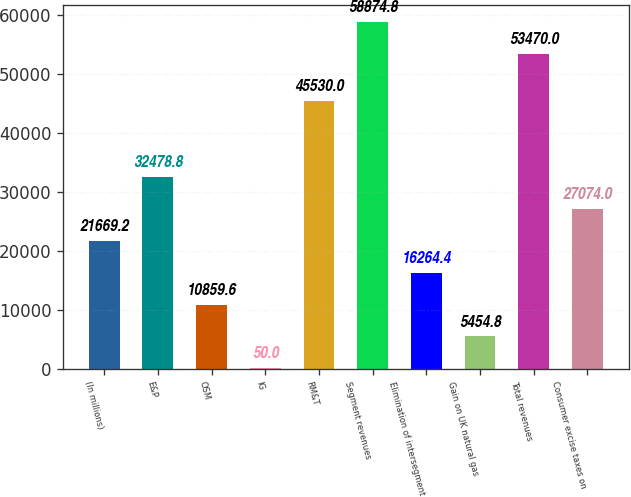Convert chart. <chart><loc_0><loc_0><loc_500><loc_500><bar_chart><fcel>(In millions)<fcel>E&P<fcel>OSM<fcel>IG<fcel>RM&T<fcel>Segment revenues<fcel>Elimination of intersegment<fcel>Gain on UK natural gas<fcel>Total revenues<fcel>Consumer excise taxes on<nl><fcel>21669.2<fcel>32478.8<fcel>10859.6<fcel>50<fcel>45530<fcel>58874.8<fcel>16264.4<fcel>5454.8<fcel>53470<fcel>27074<nl></chart> 